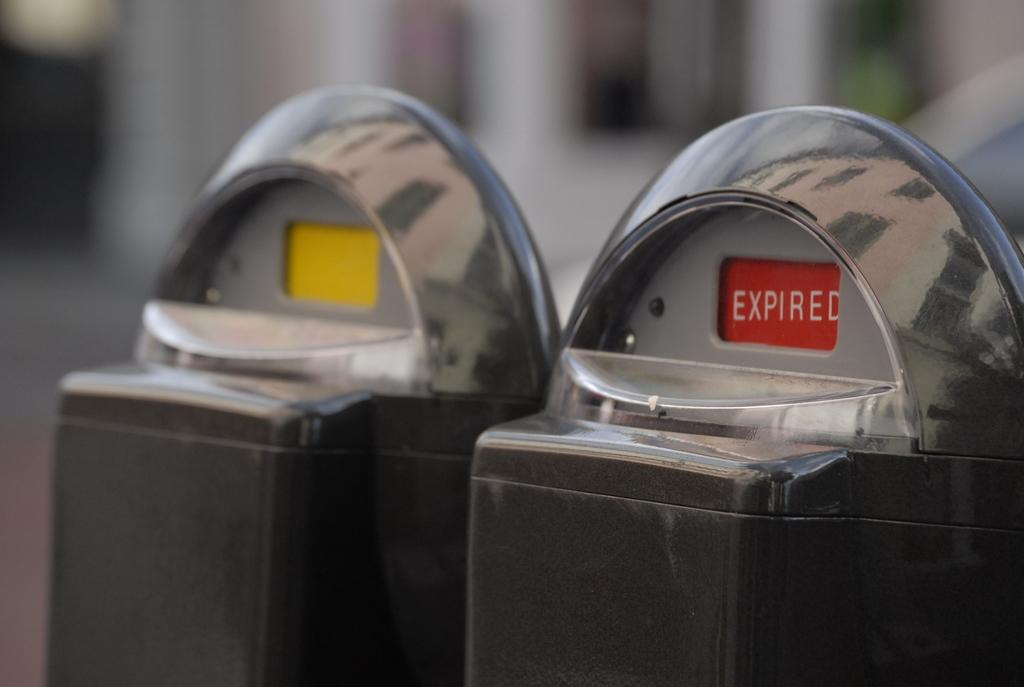<image>
Give a short and clear explanation of the subsequent image. A parking meter is displaying the word expired on a red background. 